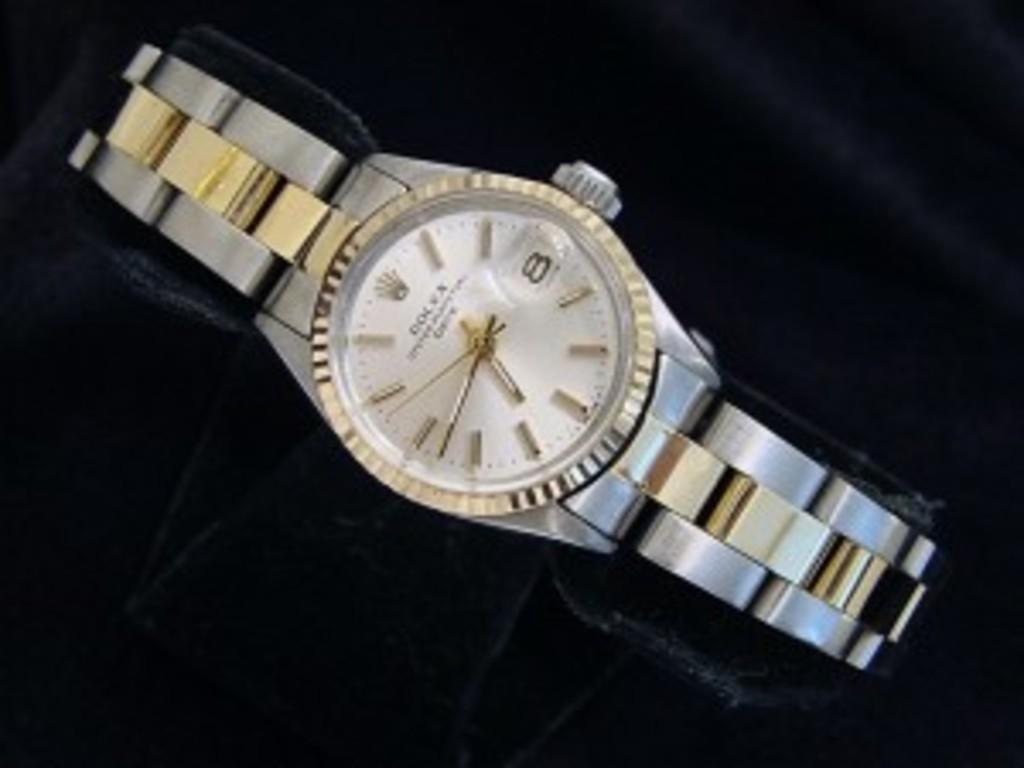<image>
Offer a succinct explanation of the picture presented. A gold and silver watch with the digit 8 on the right side. 